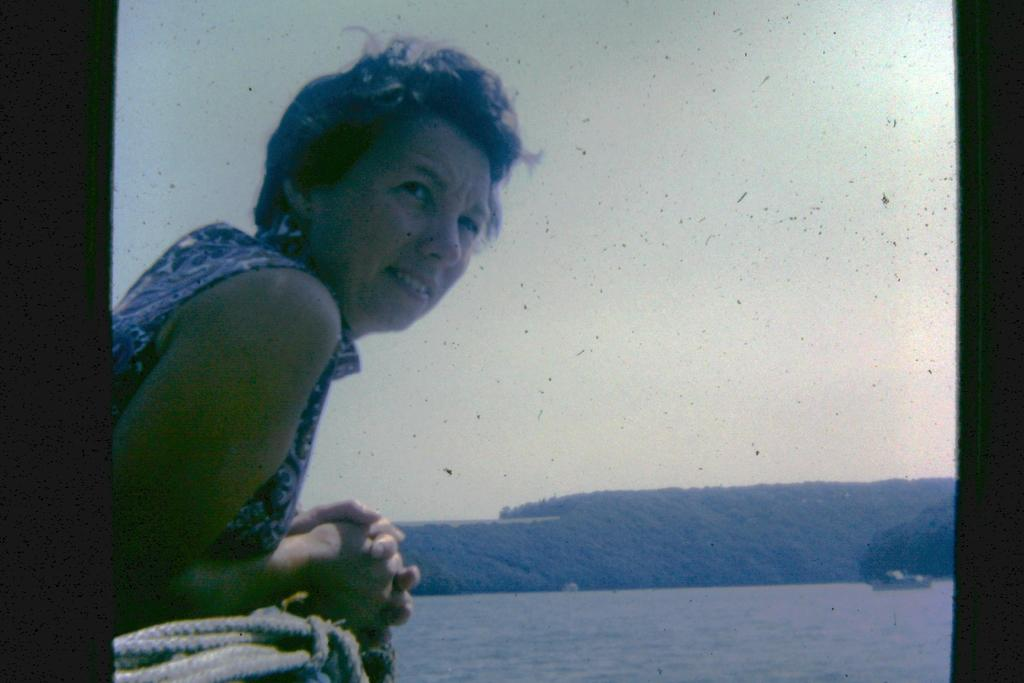Who is present in the image? There is a woman in the image. Where is the woman located in the image? The woman is on the left side of the image. What is beside the woman in the image? There is a rope beside the woman. What is in front of the woman in the image? There is a river in front of the woman. What can be seen in the background of the image? There are trees and the sky visible in the background of the image. What type of fear is the woman experiencing in the image? There is no indication of fear in the image; the woman's emotions or feelings are not mentioned. Can you tell me how many candles are on the birthday cake in the image? There is no birthday cake present in the image, so it is not possible to determine the number of candles. 